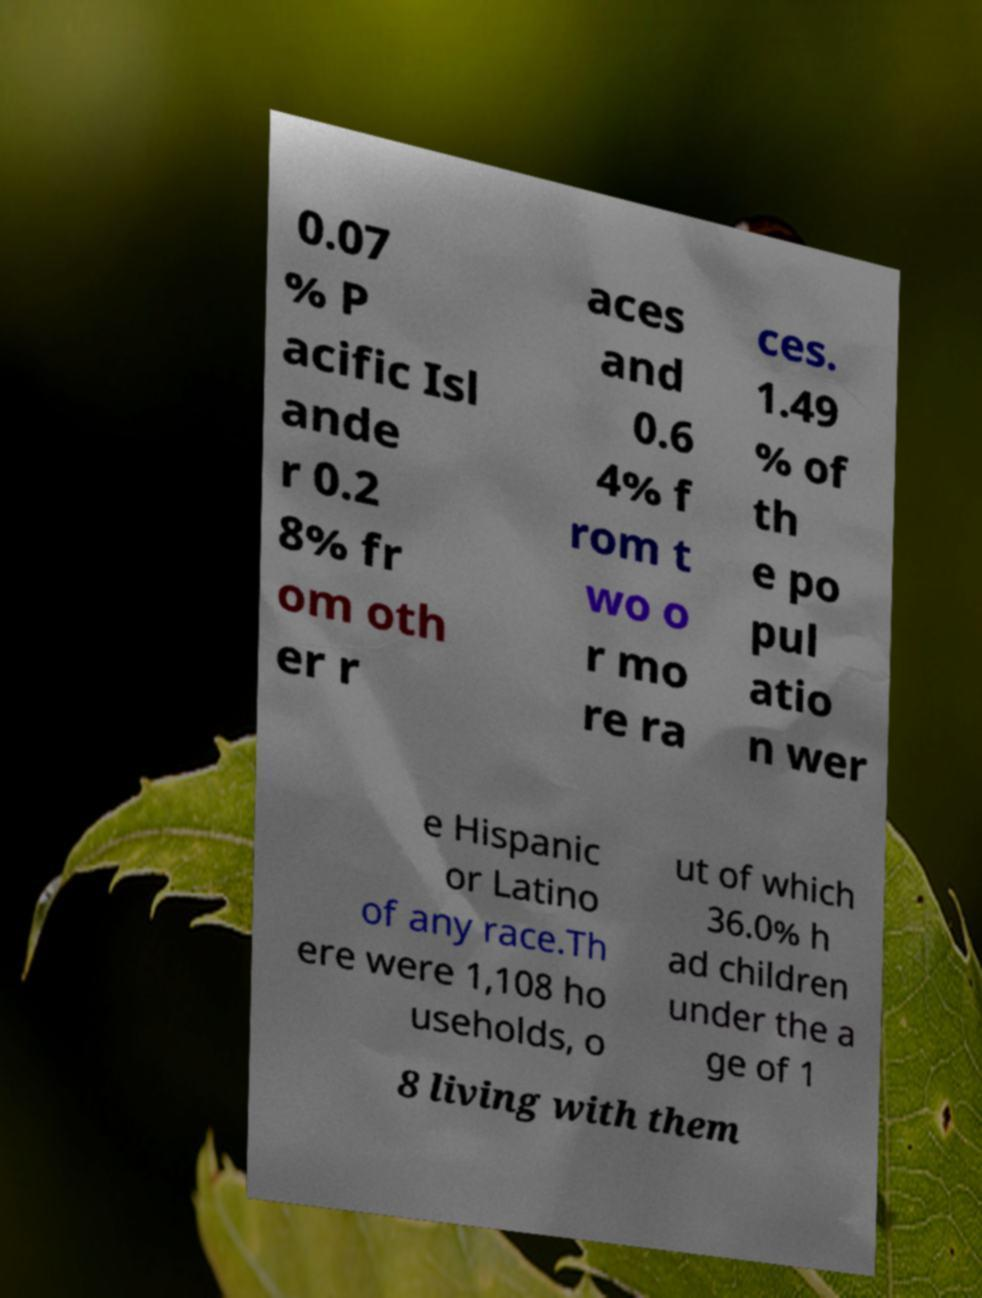Can you accurately transcribe the text from the provided image for me? 0.07 % P acific Isl ande r 0.2 8% fr om oth er r aces and 0.6 4% f rom t wo o r mo re ra ces. 1.49 % of th e po pul atio n wer e Hispanic or Latino of any race.Th ere were 1,108 ho useholds, o ut of which 36.0% h ad children under the a ge of 1 8 living with them 